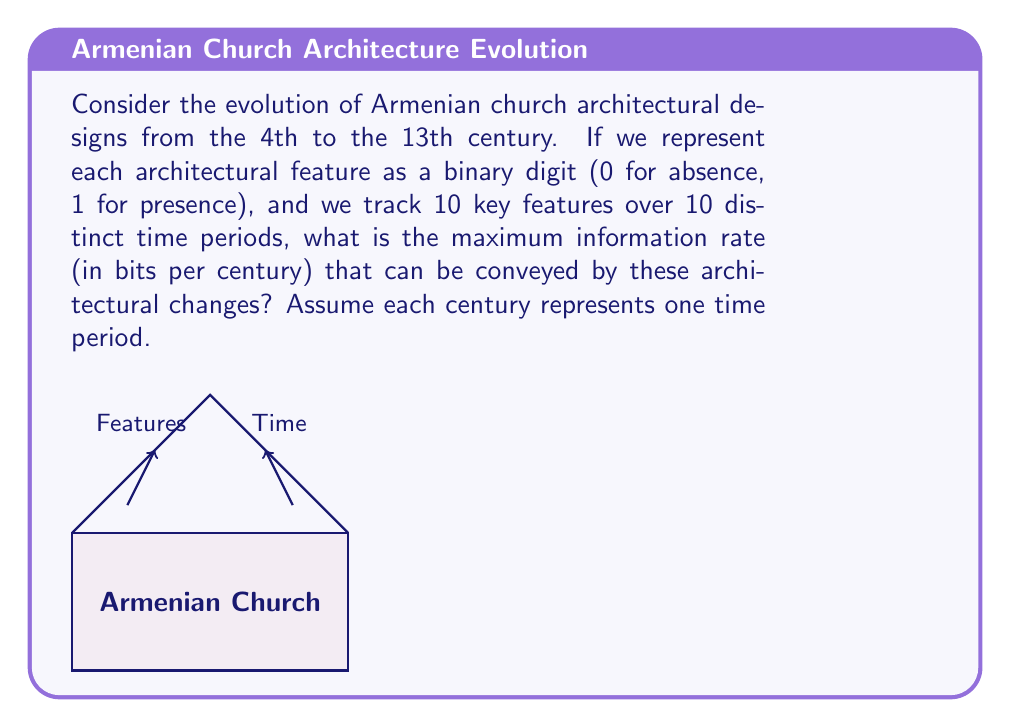Can you answer this question? To solve this problem, we need to follow these steps:

1) First, let's understand what we're given:
   - 10 key features
   - 10 time periods (centuries)
   - Each feature is binary (present or absent)

2) In information theory, the maximum information rate is achieved when all possible states are equally likely. In this case, that means each feature has an equal probability of being present or absent in each time period.

3) The total number of possible states for each time period is:
   $$2^{10} = 1024$$
   (because each of the 10 features can be either 0 or 1)

4) The information content of each state is:
   $$\log_2(1024) = 10 \text{ bits}$$

5) Over 10 time periods, the total information content is:
   $$10 \times 10 = 100 \text{ bits}$$

6) To get the rate per century, we divide by the number of centuries:
   $$\frac{100 \text{ bits}}{10 \text{ centuries}} = 10 \text{ bits/century}$$

Therefore, the maximum information rate that can be conveyed by these architectural changes is 10 bits per century.
Answer: 10 bits/century 